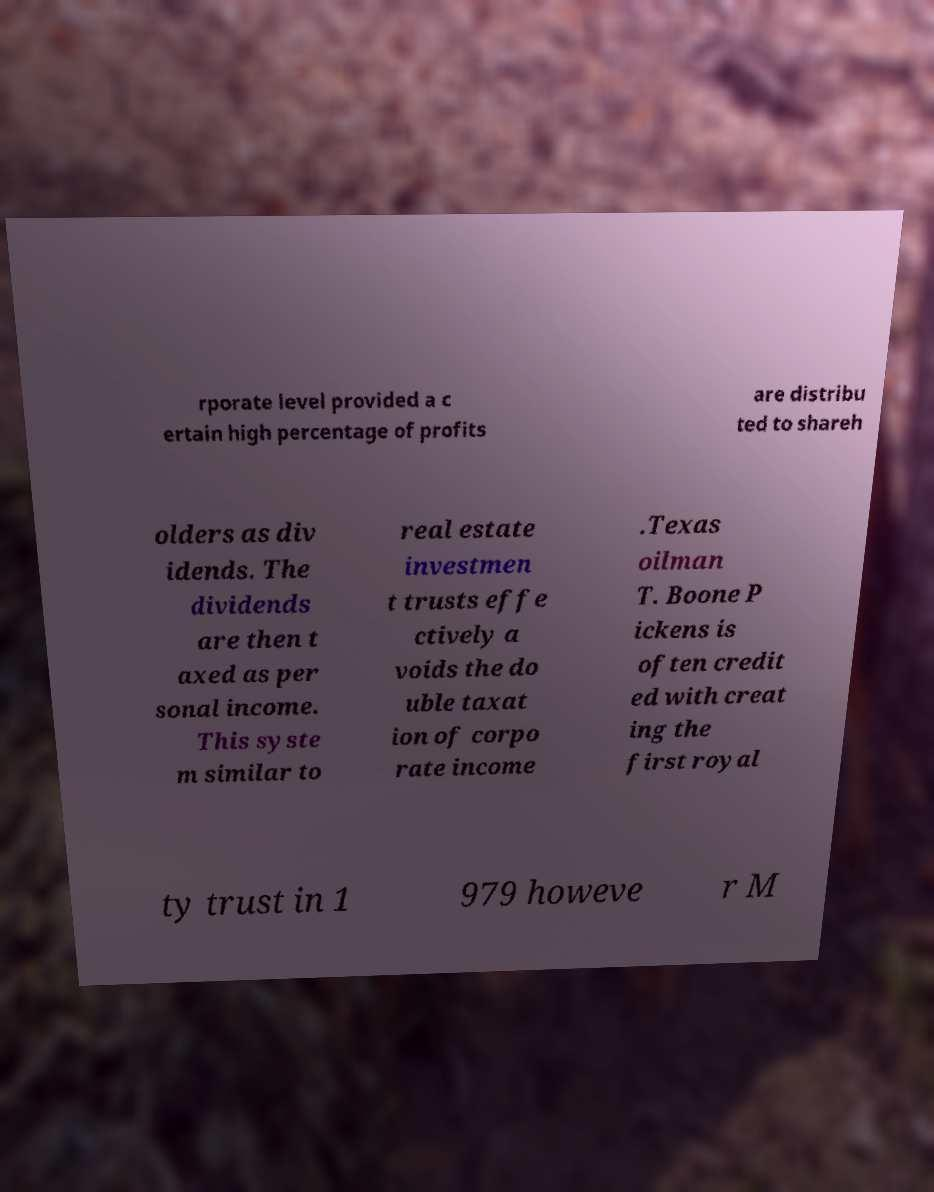There's text embedded in this image that I need extracted. Can you transcribe it verbatim? rporate level provided a c ertain high percentage of profits are distribu ted to shareh olders as div idends. The dividends are then t axed as per sonal income. This syste m similar to real estate investmen t trusts effe ctively a voids the do uble taxat ion of corpo rate income .Texas oilman T. Boone P ickens is often credit ed with creat ing the first royal ty trust in 1 979 howeve r M 